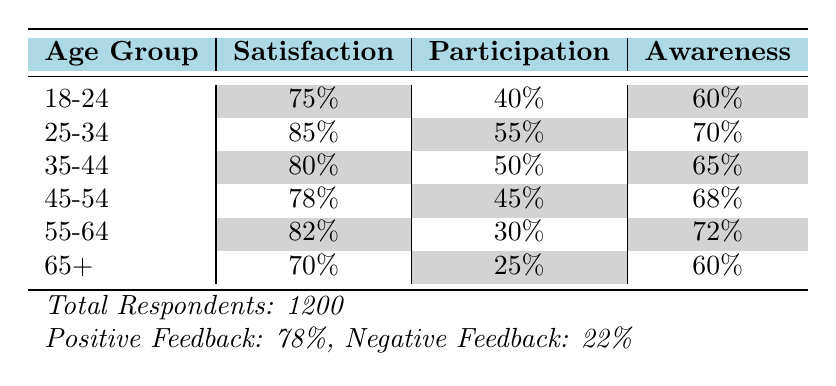What is the satisfaction percentage for the age group 25-34? The table clearly shows that the satisfaction percentage for the age group 25-34 is indicated in the Satisfaction column next to the corresponding age group. Thus, we directly read the value from the table.
Answer: 85% Which age group has the lowest participation rate? By comparing the Participation column across all age groups in the table, we can see that the age group 65+ has the lowest participation percentage of 25%.
Answer: 65+ What is the average satisfaction percentage across all age groups? To find the average satisfaction, we first sum the satisfaction percentages: 75 + 85 + 80 + 78 + 82 + 70 = 470. Then, we divide this total by the number of age groups (6): 470 / 6 = 78.33, which we can round to 78.33%.
Answer: 78.33% Is the satisfaction percentage for the age group 45-54 higher than that of the age group 35-44? We compare the satisfaction percentages given in the Satisfaction column: 78% for 45-54 and 80% for 35-44. Since 78% is less than 80%, the statement is false.
Answer: No Which age group shows both the highest awareness and satisfaction levels? We can evaluate the Awareness and Satisfaction columns to find both highest values. The age group 25-34 has the highest satisfaction at 85% and an awareness of 70%. The age group 55-64 has the highest awareness at 72%. However, no age group has the highest value for both categories; thus, there isn't one that meets the criteria.
Answer: None 